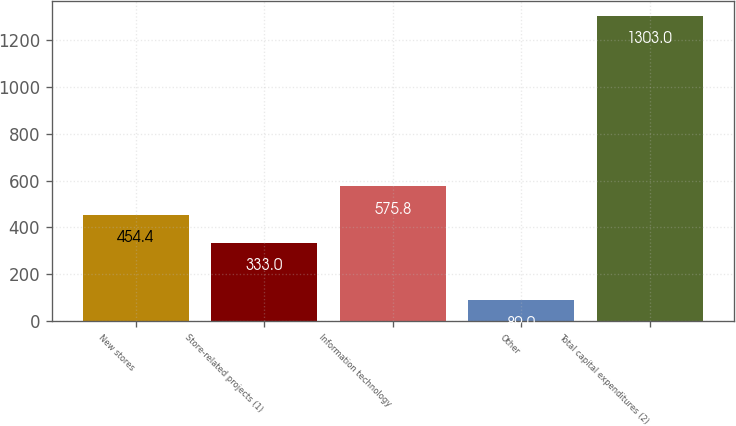Convert chart. <chart><loc_0><loc_0><loc_500><loc_500><bar_chart><fcel>New stores<fcel>Store-related projects (1)<fcel>Information technology<fcel>Other<fcel>Total capital expenditures (2)<nl><fcel>454.4<fcel>333<fcel>575.8<fcel>89<fcel>1303<nl></chart> 